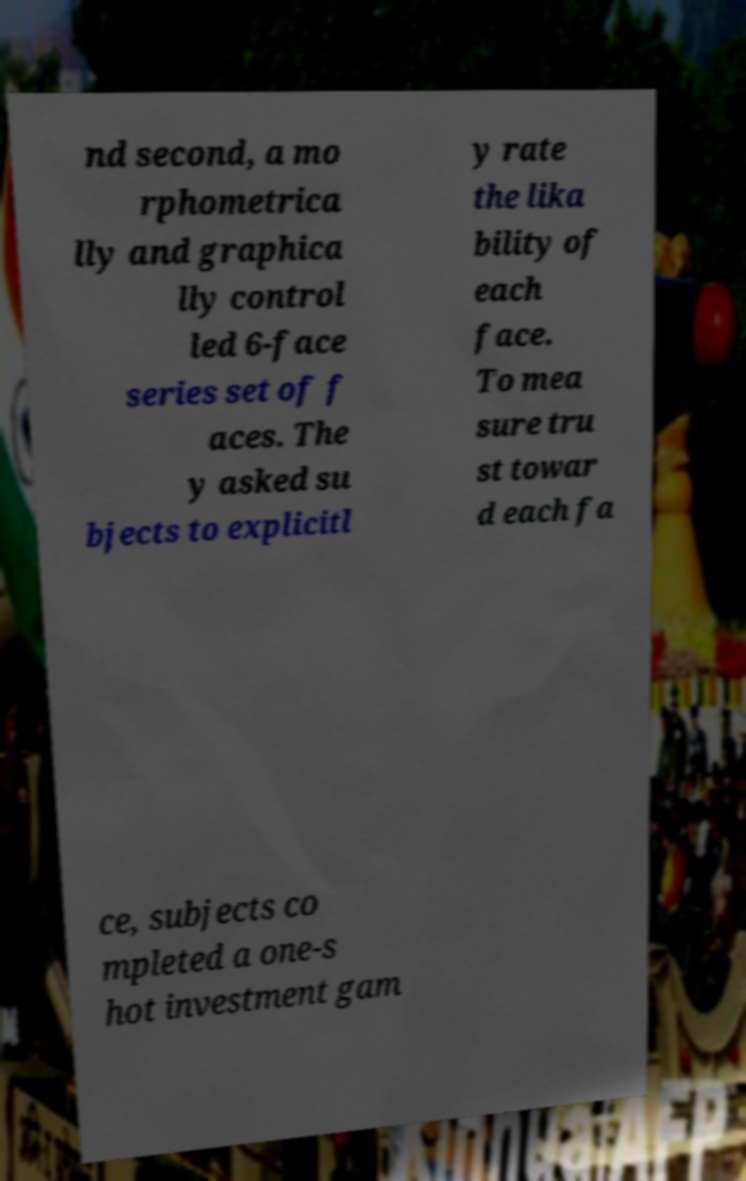Please read and relay the text visible in this image. What does it say? nd second, a mo rphometrica lly and graphica lly control led 6-face series set of f aces. The y asked su bjects to explicitl y rate the lika bility of each face. To mea sure tru st towar d each fa ce, subjects co mpleted a one-s hot investment gam 